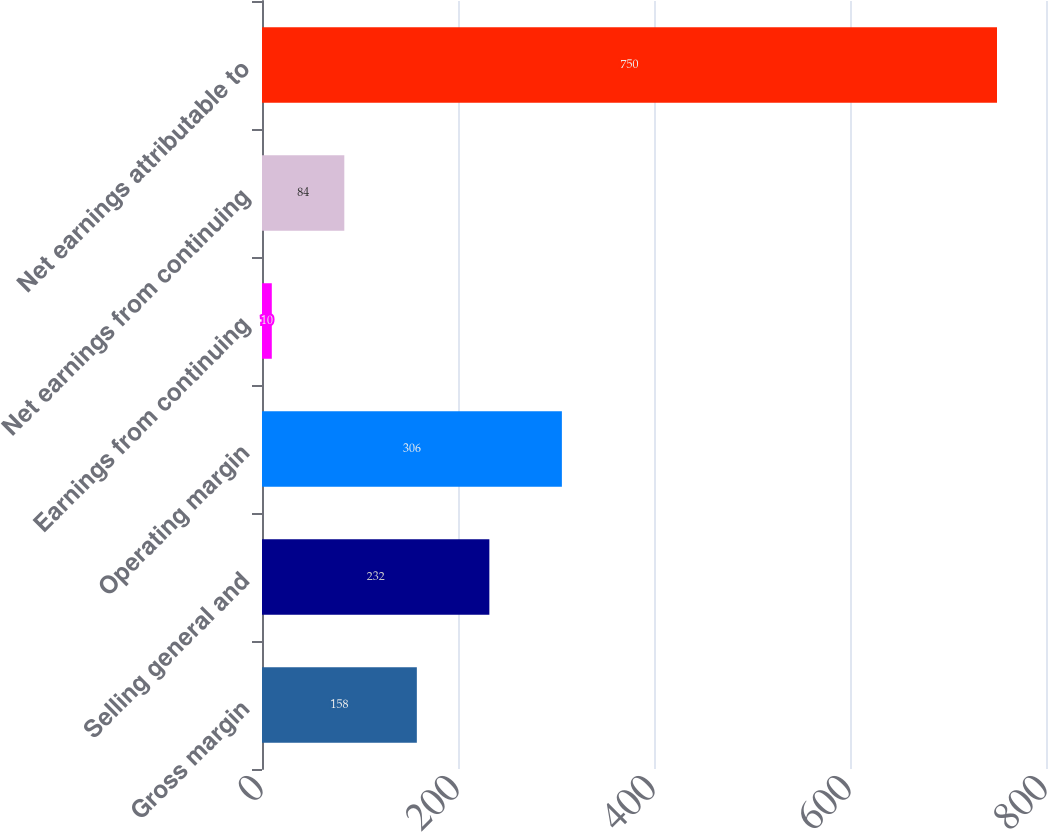Convert chart. <chart><loc_0><loc_0><loc_500><loc_500><bar_chart><fcel>Gross margin<fcel>Selling general and<fcel>Operating margin<fcel>Earnings from continuing<fcel>Net earnings from continuing<fcel>Net earnings attributable to<nl><fcel>158<fcel>232<fcel>306<fcel>10<fcel>84<fcel>750<nl></chart> 